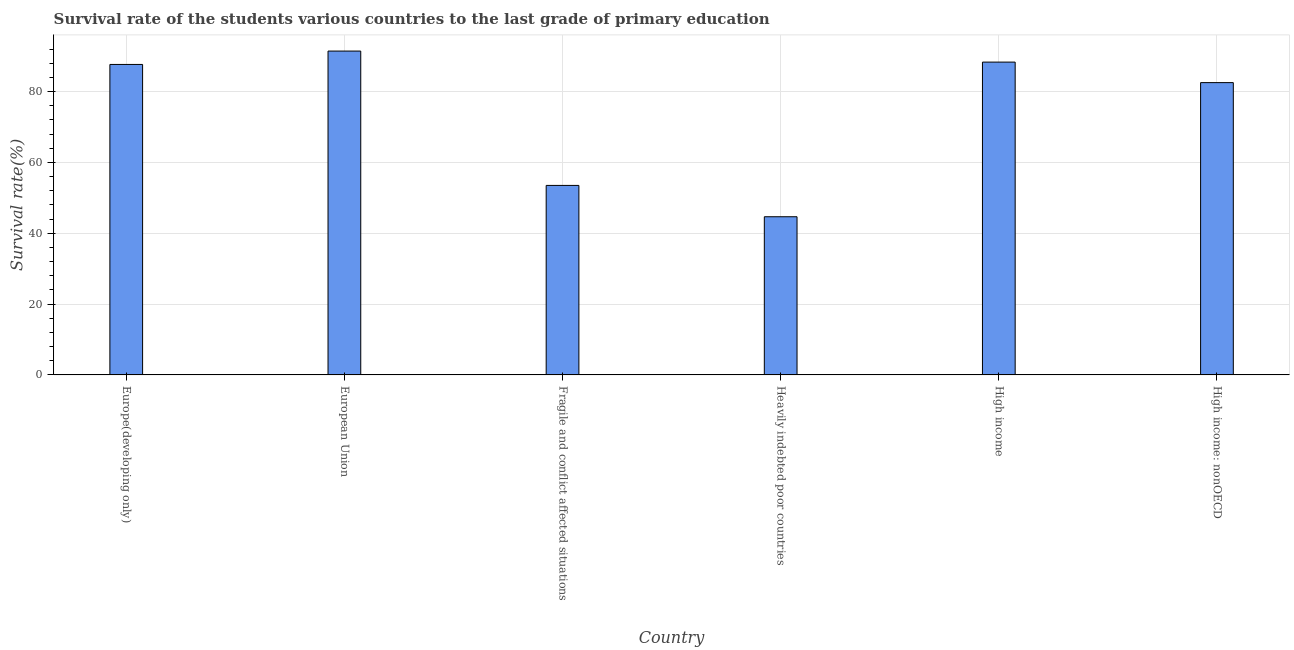What is the title of the graph?
Your response must be concise. Survival rate of the students various countries to the last grade of primary education. What is the label or title of the X-axis?
Offer a terse response. Country. What is the label or title of the Y-axis?
Keep it short and to the point. Survival rate(%). What is the survival rate in primary education in Heavily indebted poor countries?
Your answer should be very brief. 44.65. Across all countries, what is the maximum survival rate in primary education?
Provide a succinct answer. 91.42. Across all countries, what is the minimum survival rate in primary education?
Your answer should be very brief. 44.65. In which country was the survival rate in primary education minimum?
Your answer should be compact. Heavily indebted poor countries. What is the sum of the survival rate in primary education?
Provide a short and direct response. 448.04. What is the difference between the survival rate in primary education in European Union and Heavily indebted poor countries?
Your response must be concise. 46.77. What is the average survival rate in primary education per country?
Offer a very short reply. 74.67. What is the median survival rate in primary education?
Make the answer very short. 85.08. What is the ratio of the survival rate in primary education in High income to that in High income: nonOECD?
Offer a very short reply. 1.07. Is the survival rate in primary education in European Union less than that in Heavily indebted poor countries?
Offer a terse response. No. What is the difference between the highest and the second highest survival rate in primary education?
Your response must be concise. 3.12. What is the difference between the highest and the lowest survival rate in primary education?
Offer a very short reply. 46.77. In how many countries, is the survival rate in primary education greater than the average survival rate in primary education taken over all countries?
Your response must be concise. 4. How many bars are there?
Give a very brief answer. 6. Are all the bars in the graph horizontal?
Provide a short and direct response. No. What is the Survival rate(%) in Europe(developing only)?
Ensure brevity in your answer.  87.65. What is the Survival rate(%) in European Union?
Your answer should be compact. 91.42. What is the Survival rate(%) in Fragile and conflict affected situations?
Offer a terse response. 53.5. What is the Survival rate(%) of Heavily indebted poor countries?
Your answer should be compact. 44.65. What is the Survival rate(%) in High income?
Your response must be concise. 88.31. What is the Survival rate(%) of High income: nonOECD?
Your response must be concise. 82.51. What is the difference between the Survival rate(%) in Europe(developing only) and European Union?
Offer a very short reply. -3.78. What is the difference between the Survival rate(%) in Europe(developing only) and Fragile and conflict affected situations?
Your answer should be compact. 34.15. What is the difference between the Survival rate(%) in Europe(developing only) and Heavily indebted poor countries?
Your answer should be compact. 42.99. What is the difference between the Survival rate(%) in Europe(developing only) and High income?
Your answer should be compact. -0.66. What is the difference between the Survival rate(%) in Europe(developing only) and High income: nonOECD?
Ensure brevity in your answer.  5.13. What is the difference between the Survival rate(%) in European Union and Fragile and conflict affected situations?
Your response must be concise. 37.93. What is the difference between the Survival rate(%) in European Union and Heavily indebted poor countries?
Your answer should be compact. 46.77. What is the difference between the Survival rate(%) in European Union and High income?
Your answer should be very brief. 3.11. What is the difference between the Survival rate(%) in European Union and High income: nonOECD?
Keep it short and to the point. 8.91. What is the difference between the Survival rate(%) in Fragile and conflict affected situations and Heavily indebted poor countries?
Your answer should be very brief. 8.84. What is the difference between the Survival rate(%) in Fragile and conflict affected situations and High income?
Provide a succinct answer. -34.81. What is the difference between the Survival rate(%) in Fragile and conflict affected situations and High income: nonOECD?
Offer a very short reply. -29.02. What is the difference between the Survival rate(%) in Heavily indebted poor countries and High income?
Provide a succinct answer. -43.65. What is the difference between the Survival rate(%) in Heavily indebted poor countries and High income: nonOECD?
Give a very brief answer. -37.86. What is the difference between the Survival rate(%) in High income and High income: nonOECD?
Your response must be concise. 5.79. What is the ratio of the Survival rate(%) in Europe(developing only) to that in Fragile and conflict affected situations?
Your response must be concise. 1.64. What is the ratio of the Survival rate(%) in Europe(developing only) to that in Heavily indebted poor countries?
Offer a very short reply. 1.96. What is the ratio of the Survival rate(%) in Europe(developing only) to that in High income: nonOECD?
Your response must be concise. 1.06. What is the ratio of the Survival rate(%) in European Union to that in Fragile and conflict affected situations?
Your answer should be compact. 1.71. What is the ratio of the Survival rate(%) in European Union to that in Heavily indebted poor countries?
Give a very brief answer. 2.05. What is the ratio of the Survival rate(%) in European Union to that in High income?
Your answer should be compact. 1.03. What is the ratio of the Survival rate(%) in European Union to that in High income: nonOECD?
Provide a short and direct response. 1.11. What is the ratio of the Survival rate(%) in Fragile and conflict affected situations to that in Heavily indebted poor countries?
Offer a very short reply. 1.2. What is the ratio of the Survival rate(%) in Fragile and conflict affected situations to that in High income?
Ensure brevity in your answer.  0.61. What is the ratio of the Survival rate(%) in Fragile and conflict affected situations to that in High income: nonOECD?
Provide a short and direct response. 0.65. What is the ratio of the Survival rate(%) in Heavily indebted poor countries to that in High income?
Keep it short and to the point. 0.51. What is the ratio of the Survival rate(%) in Heavily indebted poor countries to that in High income: nonOECD?
Provide a short and direct response. 0.54. What is the ratio of the Survival rate(%) in High income to that in High income: nonOECD?
Keep it short and to the point. 1.07. 